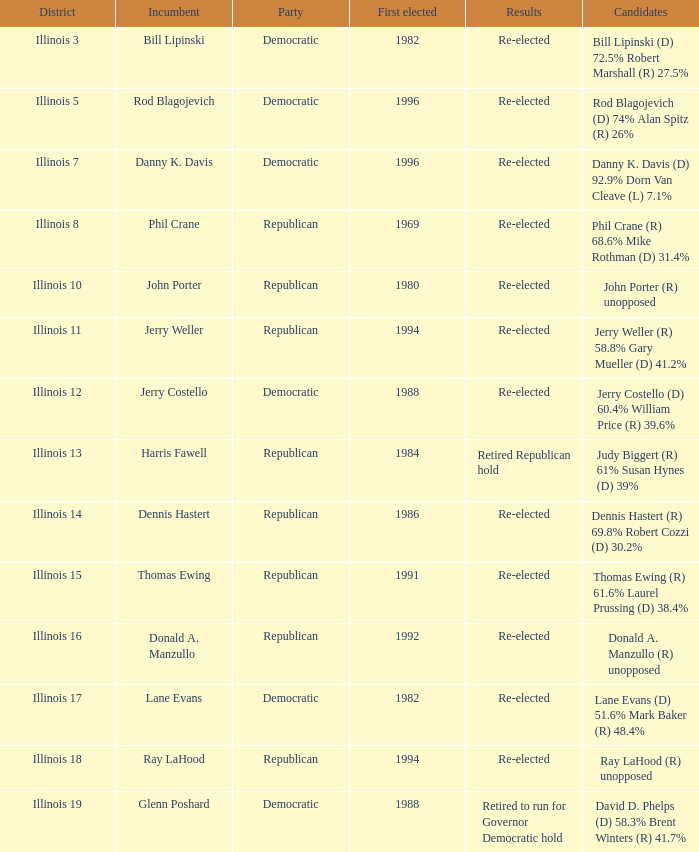Could you parse the entire table? {'header': ['District', 'Incumbent', 'Party', 'First elected', 'Results', 'Candidates'], 'rows': [['Illinois 3', 'Bill Lipinski', 'Democratic', '1982', 'Re-elected', 'Bill Lipinski (D) 72.5% Robert Marshall (R) 27.5%'], ['Illinois 5', 'Rod Blagojevich', 'Democratic', '1996', 'Re-elected', 'Rod Blagojevich (D) 74% Alan Spitz (R) 26%'], ['Illinois 7', 'Danny K. Davis', 'Democratic', '1996', 'Re-elected', 'Danny K. Davis (D) 92.9% Dorn Van Cleave (L) 7.1%'], ['Illinois 8', 'Phil Crane', 'Republican', '1969', 'Re-elected', 'Phil Crane (R) 68.6% Mike Rothman (D) 31.4%'], ['Illinois 10', 'John Porter', 'Republican', '1980', 'Re-elected', 'John Porter (R) unopposed'], ['Illinois 11', 'Jerry Weller', 'Republican', '1994', 'Re-elected', 'Jerry Weller (R) 58.8% Gary Mueller (D) 41.2%'], ['Illinois 12', 'Jerry Costello', 'Democratic', '1988', 'Re-elected', 'Jerry Costello (D) 60.4% William Price (R) 39.6%'], ['Illinois 13', 'Harris Fawell', 'Republican', '1984', 'Retired Republican hold', 'Judy Biggert (R) 61% Susan Hynes (D) 39%'], ['Illinois 14', 'Dennis Hastert', 'Republican', '1986', 'Re-elected', 'Dennis Hastert (R) 69.8% Robert Cozzi (D) 30.2%'], ['Illinois 15', 'Thomas Ewing', 'Republican', '1991', 'Re-elected', 'Thomas Ewing (R) 61.6% Laurel Prussing (D) 38.4%'], ['Illinois 16', 'Donald A. Manzullo', 'Republican', '1992', 'Re-elected', 'Donald A. Manzullo (R) unopposed'], ['Illinois 17', 'Lane Evans', 'Democratic', '1982', 'Re-elected', 'Lane Evans (D) 51.6% Mark Baker (R) 48.4%'], ['Illinois 18', 'Ray LaHood', 'Republican', '1994', 'Re-elected', 'Ray LaHood (R) unopposed'], ['Illinois 19', 'Glenn Poshard', 'Democratic', '1988', 'Retired to run for Governor Democratic hold', 'David D. Phelps (D) 58.3% Brent Winters (R) 41.7%']]} What district was John Porter elected in? Illinois 10. 